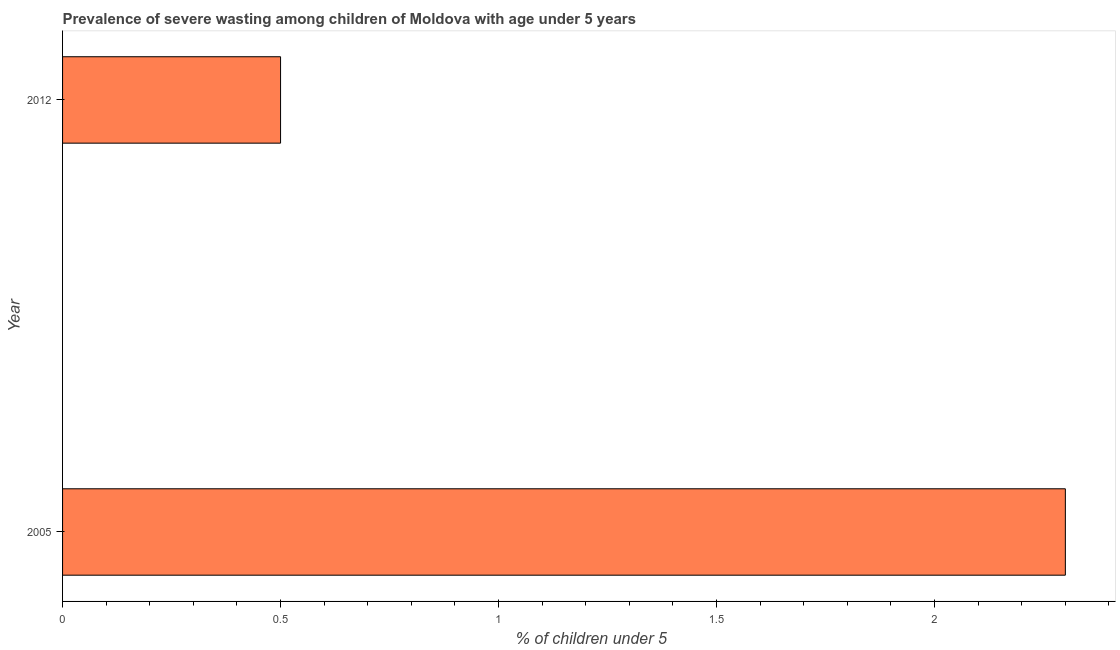Does the graph contain any zero values?
Keep it short and to the point. No. Does the graph contain grids?
Your answer should be very brief. No. What is the title of the graph?
Give a very brief answer. Prevalence of severe wasting among children of Moldova with age under 5 years. What is the label or title of the X-axis?
Offer a very short reply.  % of children under 5. What is the prevalence of severe wasting in 2005?
Your answer should be compact. 2.3. Across all years, what is the maximum prevalence of severe wasting?
Provide a short and direct response. 2.3. In which year was the prevalence of severe wasting maximum?
Keep it short and to the point. 2005. In which year was the prevalence of severe wasting minimum?
Make the answer very short. 2012. What is the sum of the prevalence of severe wasting?
Ensure brevity in your answer.  2.8. What is the difference between the prevalence of severe wasting in 2005 and 2012?
Your response must be concise. 1.8. What is the average prevalence of severe wasting per year?
Keep it short and to the point. 1.4. What is the median prevalence of severe wasting?
Give a very brief answer. 1.4. In how many years, is the prevalence of severe wasting greater than 0.8 %?
Offer a terse response. 1. What is the ratio of the prevalence of severe wasting in 2005 to that in 2012?
Offer a terse response. 4.6. In how many years, is the prevalence of severe wasting greater than the average prevalence of severe wasting taken over all years?
Your answer should be compact. 1. How many bars are there?
Give a very brief answer. 2. How many years are there in the graph?
Your answer should be very brief. 2. Are the values on the major ticks of X-axis written in scientific E-notation?
Offer a terse response. No. What is the  % of children under 5 of 2005?
Your answer should be compact. 2.3. What is the  % of children under 5 in 2012?
Provide a succinct answer. 0.5. What is the ratio of the  % of children under 5 in 2005 to that in 2012?
Offer a very short reply. 4.6. 